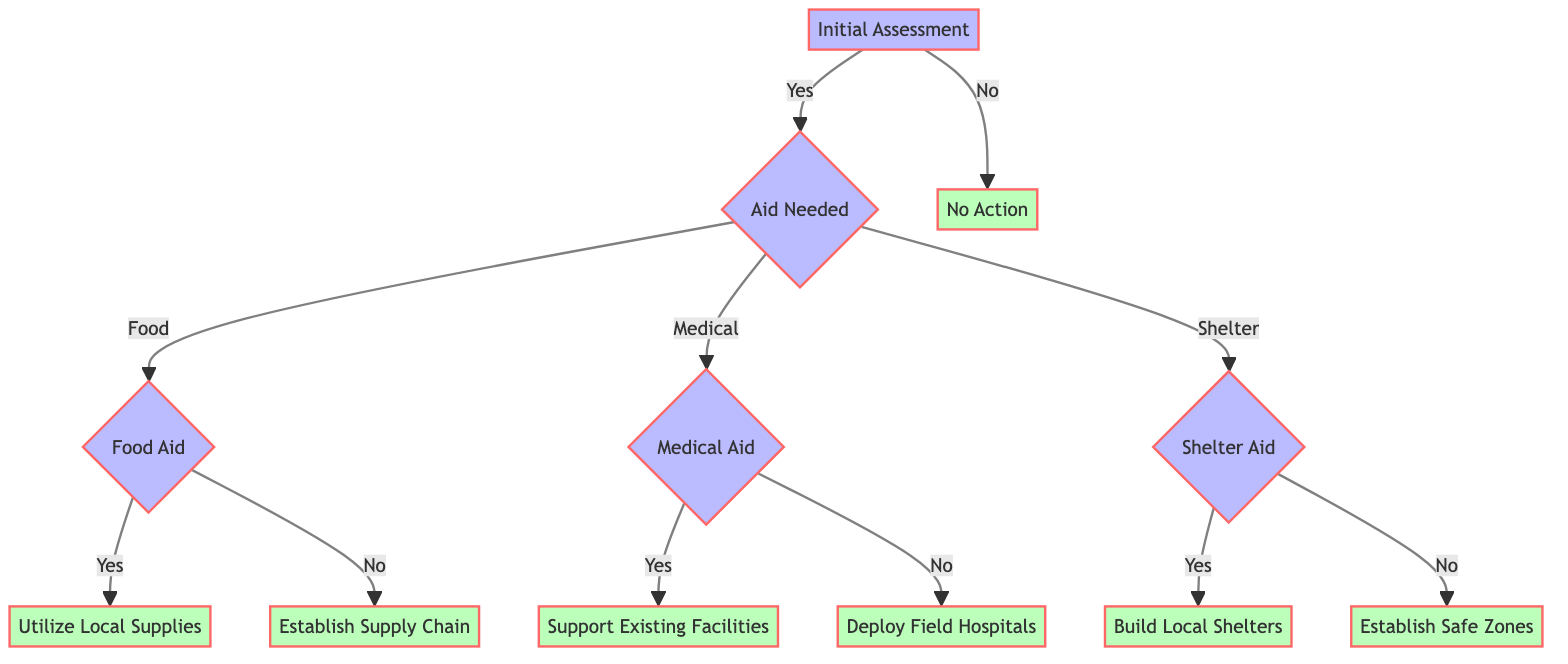What is the first question in the decision tree? The first step in the decision tree is the "Initial Assessment," which asks if there is an urgent need for humanitarian aid.
Answer: Is there an urgent need for humanitarian aid? How many types of aid are listed in the diagram? The diagram lists three types of aid: Food, Medical, and Shelter. This can be determined by examining the branches under the "Aid Needed" node.
Answer: Three What action is taken if there is an existing food supply chain? If there is an existing food supply chain, the action is to "Utilize Local Supplies," which is specified under the "Food Aid" decision.
Answer: Utilize Local Supplies What happens if local healthcare facilities are not operational? If local healthcare facilities are not operational, the next step is to "Deploy Field Hospitals," based on the evaluation of the healthcare infrastructure.
Answer: Deploy Field Hospitals Which node leads to the action of establishing new areas for temporary shelter? The action of establishing safe zones is reached through the decision path that begins with "Shelter Aid," followed by the question regarding secure locations.
Answer: Establish Safe Zones What is the outcome of determining that no action is required during the initial assessment? If no action is needed during the initial assessment, it leads directly to the action "Monitoring the situation for any changes." This indicates ongoing vigilance without immediate intervention.
Answer: Monitoring the situation for any changes What type of aid follows the question about secure locations for building temporary shelters? The type of aid specified after the secure locations question is "Shelter Aid," and the flow splits based on whether there are secure locations available for shelter construction.
Answer: Shelter Aid Which decision node immediately follows the "Deploy Field Hospitals" action? The "Deploy Field Hospitals" action does not have a subsequent decision node as it concludes that particular path of the tree. This indicates that immediate healthcare solutions are addressed without further branching.
Answer: None 